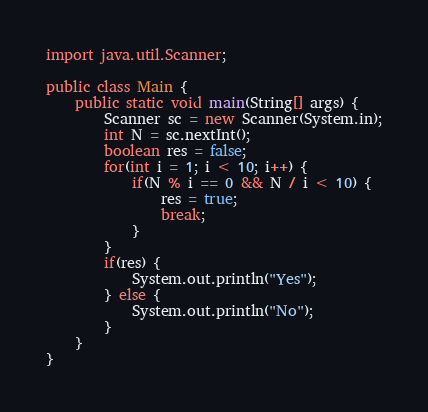<code> <loc_0><loc_0><loc_500><loc_500><_Java_>
import java.util.Scanner;

public class Main {
    public static void main(String[] args) {
        Scanner sc = new Scanner(System.in);
        int N = sc.nextInt();
        boolean res = false;
        for(int i = 1; i < 10; i++) {
            if(N % i == 0 && N / i < 10) {
                res = true;
                break;
            }
        }
        if(res) {
            System.out.println("Yes");
        } else {
            System.out.println("No");
        }
    }
}
</code> 